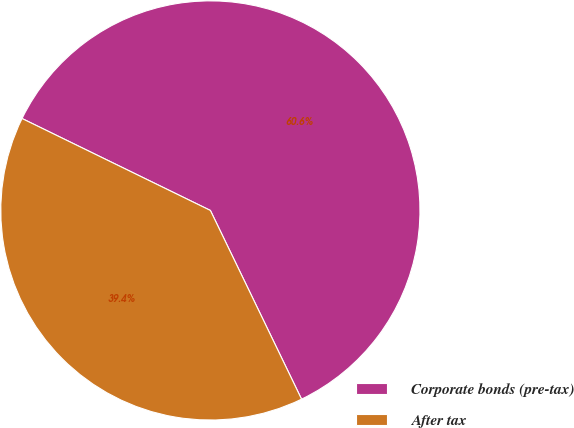<chart> <loc_0><loc_0><loc_500><loc_500><pie_chart><fcel>Corporate bonds (pre-tax)<fcel>After tax<nl><fcel>60.61%<fcel>39.39%<nl></chart> 